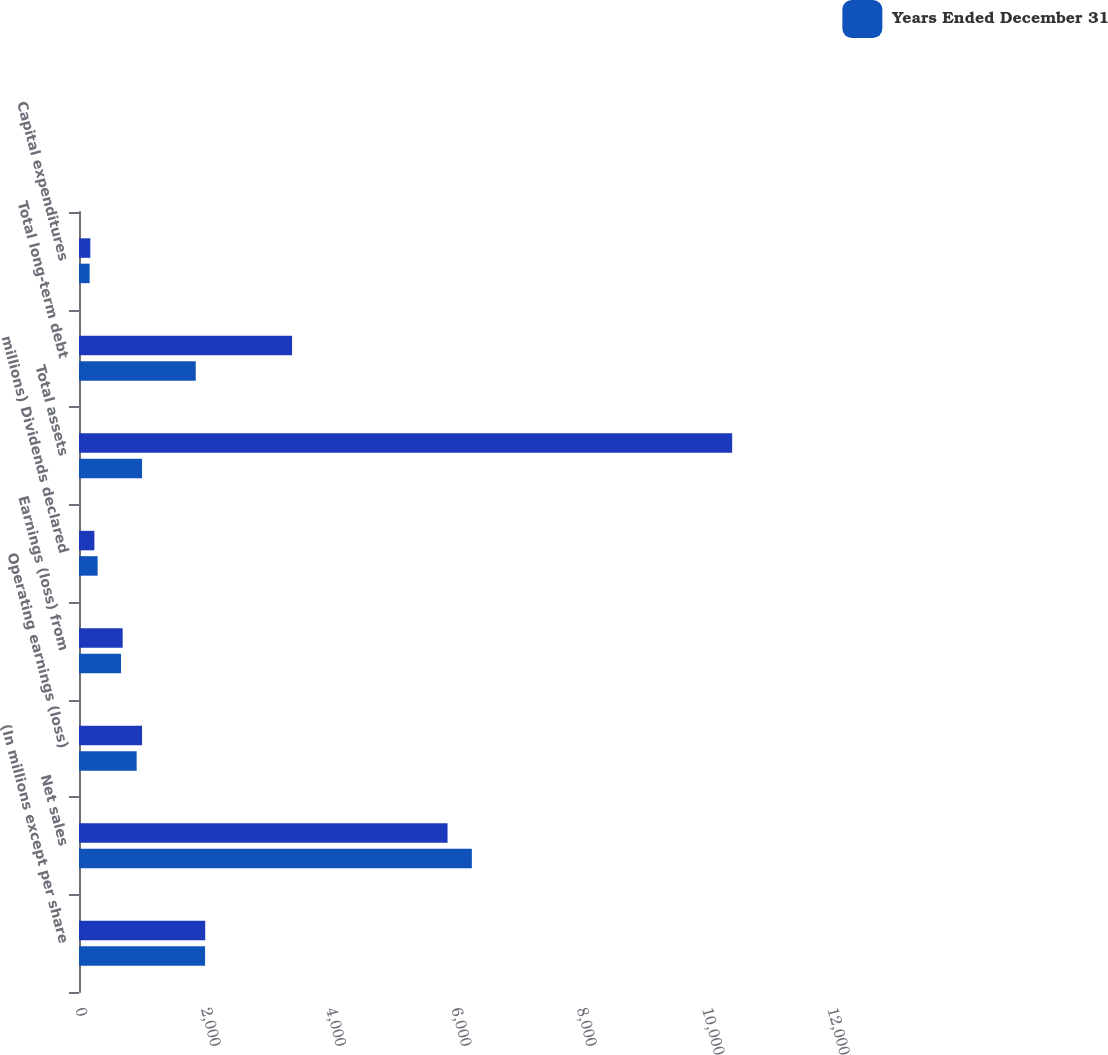Convert chart to OTSL. <chart><loc_0><loc_0><loc_500><loc_500><stacked_bar_chart><ecel><fcel>(In millions except per share<fcel>Net sales<fcel>Operating earnings (loss)<fcel>Earnings (loss) from<fcel>millions) Dividends declared<fcel>Total assets<fcel>Total long-term debt<fcel>Capital expenditures<nl><fcel>nan<fcel>2014<fcel>5881<fcel>1006<fcel>697<fcel>245.6<fcel>10423<fcel>3400<fcel>181<nl><fcel>Years Ended December 31<fcel>2012<fcel>6269<fcel>920<fcel>670<fcel>297.4<fcel>1006<fcel>1863<fcel>170<nl></chart> 